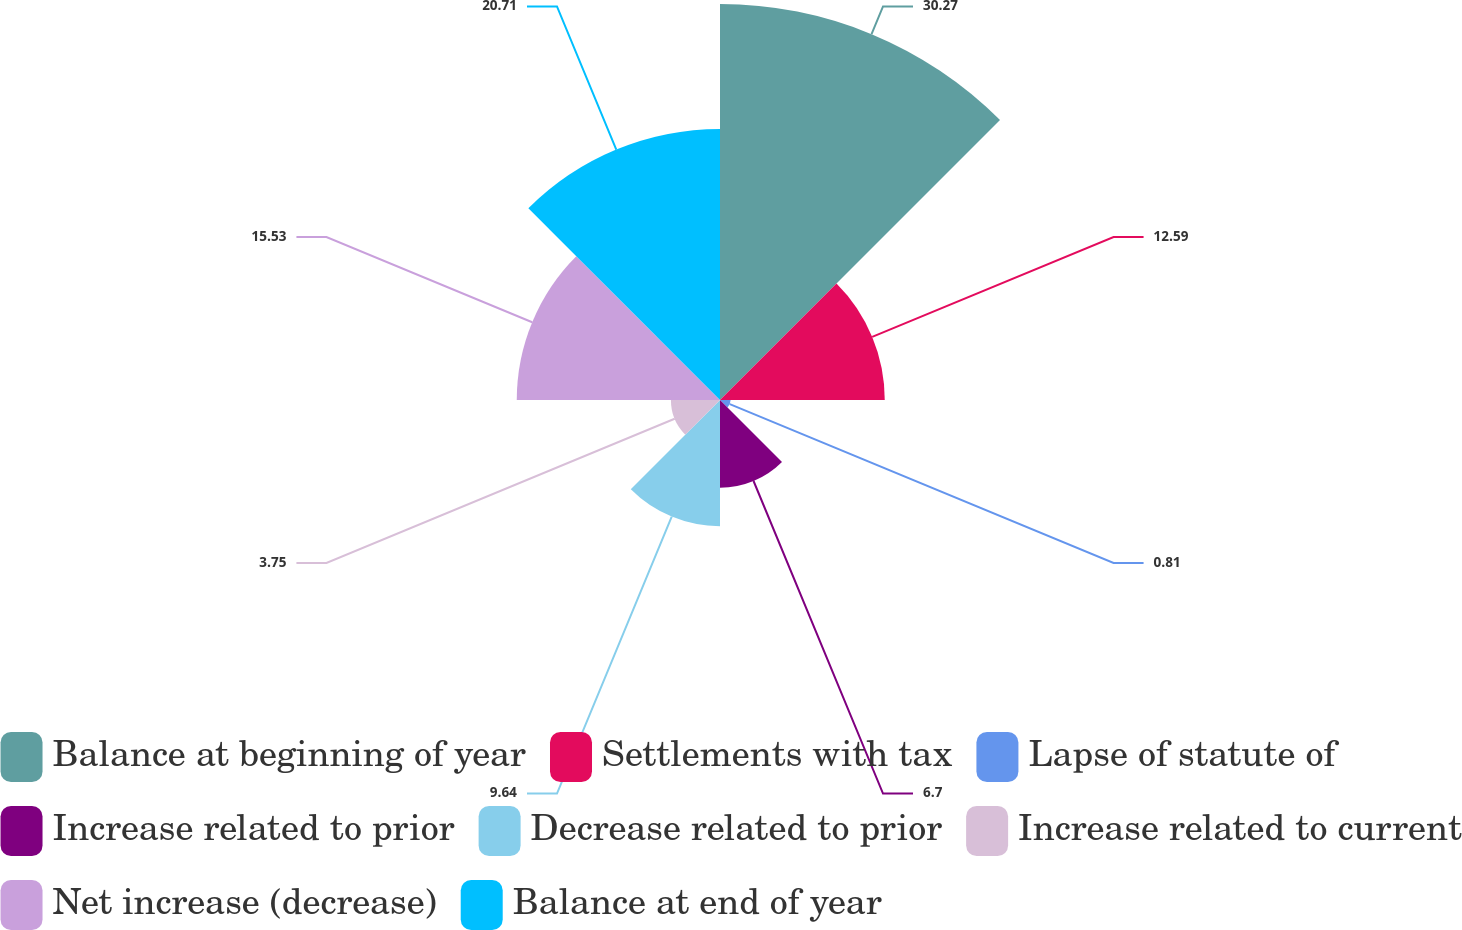Convert chart. <chart><loc_0><loc_0><loc_500><loc_500><pie_chart><fcel>Balance at beginning of year<fcel>Settlements with tax<fcel>Lapse of statute of<fcel>Increase related to prior<fcel>Decrease related to prior<fcel>Increase related to current<fcel>Net increase (decrease)<fcel>Balance at end of year<nl><fcel>30.26%<fcel>12.59%<fcel>0.81%<fcel>6.7%<fcel>9.64%<fcel>3.75%<fcel>15.53%<fcel>20.71%<nl></chart> 